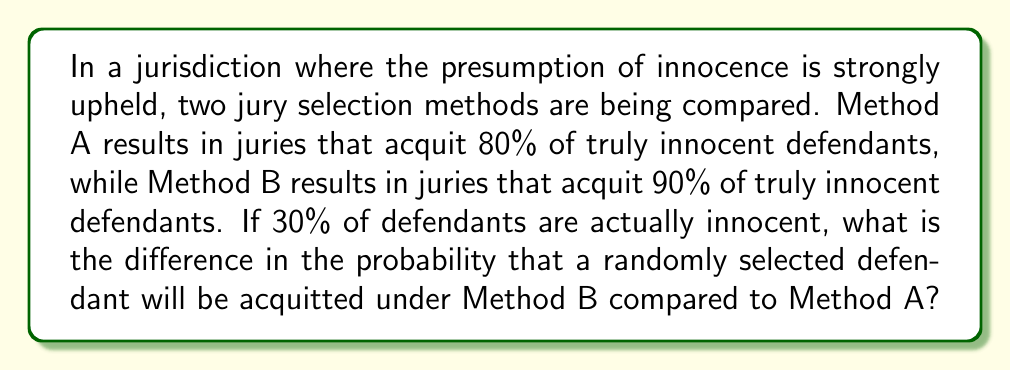Could you help me with this problem? Let's approach this step-by-step using probability theory:

1) Let's define our events:
   I: The defendant is innocent
   A: The defendant is acquitted

2) We're given the following probabilities:
   $P(I) = 0.30$ (30% of defendants are actually innocent)
   $P(A|I)_A = 0.80$ for Method A
   $P(A|I)_B = 0.90$ for Method B

3) We need to find $P(A)_B - P(A)_A$

4) Using the law of total probability:
   $P(A) = P(A|I) \cdot P(I) + P(A|\text{not }I) \cdot P(\text{not }I)$

5) We don't know $P(A|\text{not }I)$, but we can calculate it using the principle of presumption of innocence. Let's assume that juries are more likely to acquit innocent defendants than guilty ones:
   $P(A|\text{not }I)_A = 0.20$ for Method A
   $P(A|\text{not }I)_B = 0.30$ for Method B

6) Now we can calculate $P(A)$ for each method:

   For Method A:
   $$P(A)_A = 0.80 \cdot 0.30 + 0.20 \cdot 0.70 = 0.24 + 0.14 = 0.38$$

   For Method B:
   $$P(A)_B = 0.90 \cdot 0.30 + 0.30 \cdot 0.70 = 0.27 + 0.21 = 0.48$$

7) The difference is:
   $$P(A)_B - P(A)_A = 0.48 - 0.38 = 0.10$$
Answer: 0.10 or 10% 